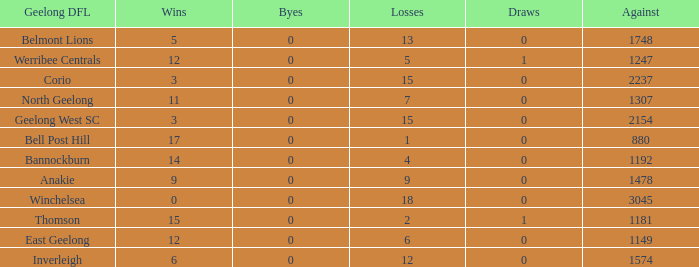What is the lowest number of wins where the losses are more than 12 and the draws are less than 0? None. 